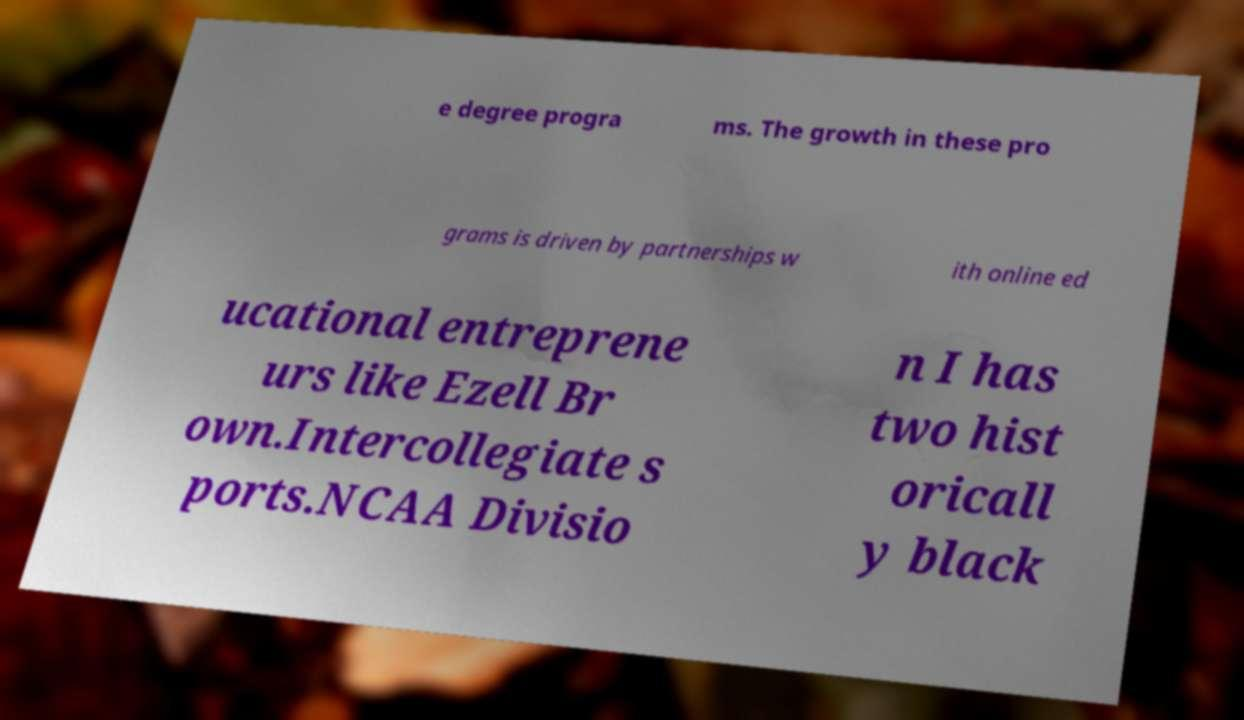Please read and relay the text visible in this image. What does it say? e degree progra ms. The growth in these pro grams is driven by partnerships w ith online ed ucational entreprene urs like Ezell Br own.Intercollegiate s ports.NCAA Divisio n I has two hist oricall y black 